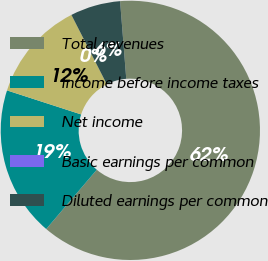Convert chart. <chart><loc_0><loc_0><loc_500><loc_500><pie_chart><fcel>Total revenues<fcel>Income before income taxes<fcel>Net income<fcel>Basic earnings per common<fcel>Diluted earnings per common<nl><fcel>62.5%<fcel>18.75%<fcel>12.5%<fcel>0.0%<fcel>6.25%<nl></chart> 